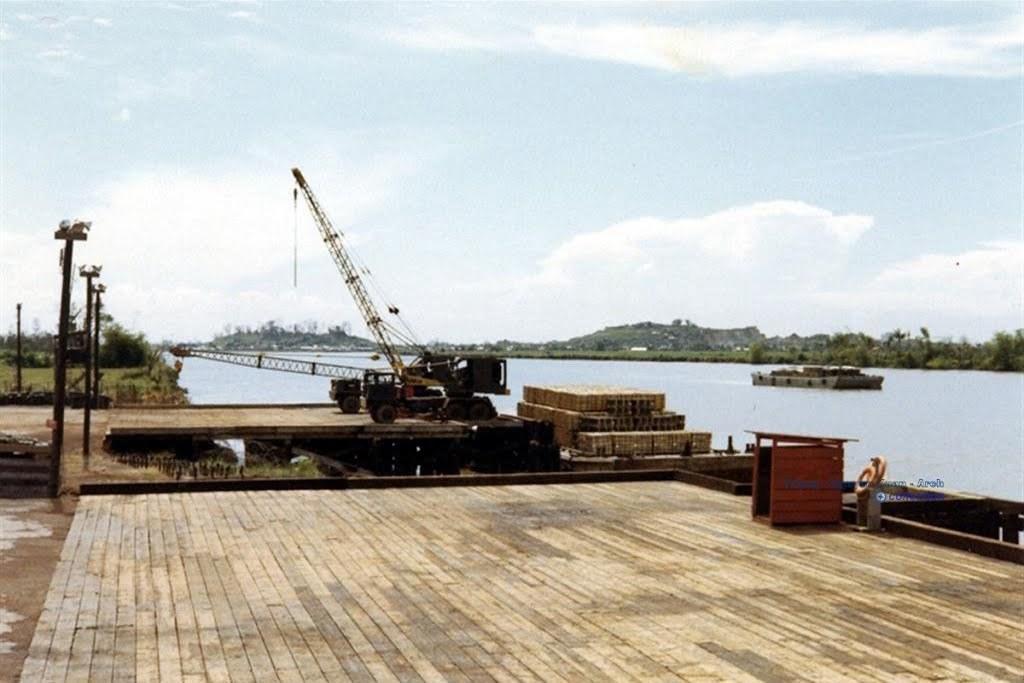Describe this image in one or two sentences. In this image we can see a crane on a wooden bridge. We can also see a house with a roof. On the backside we can see a boat on the lake, some poles, mountains and the sky which looks cloudy. 